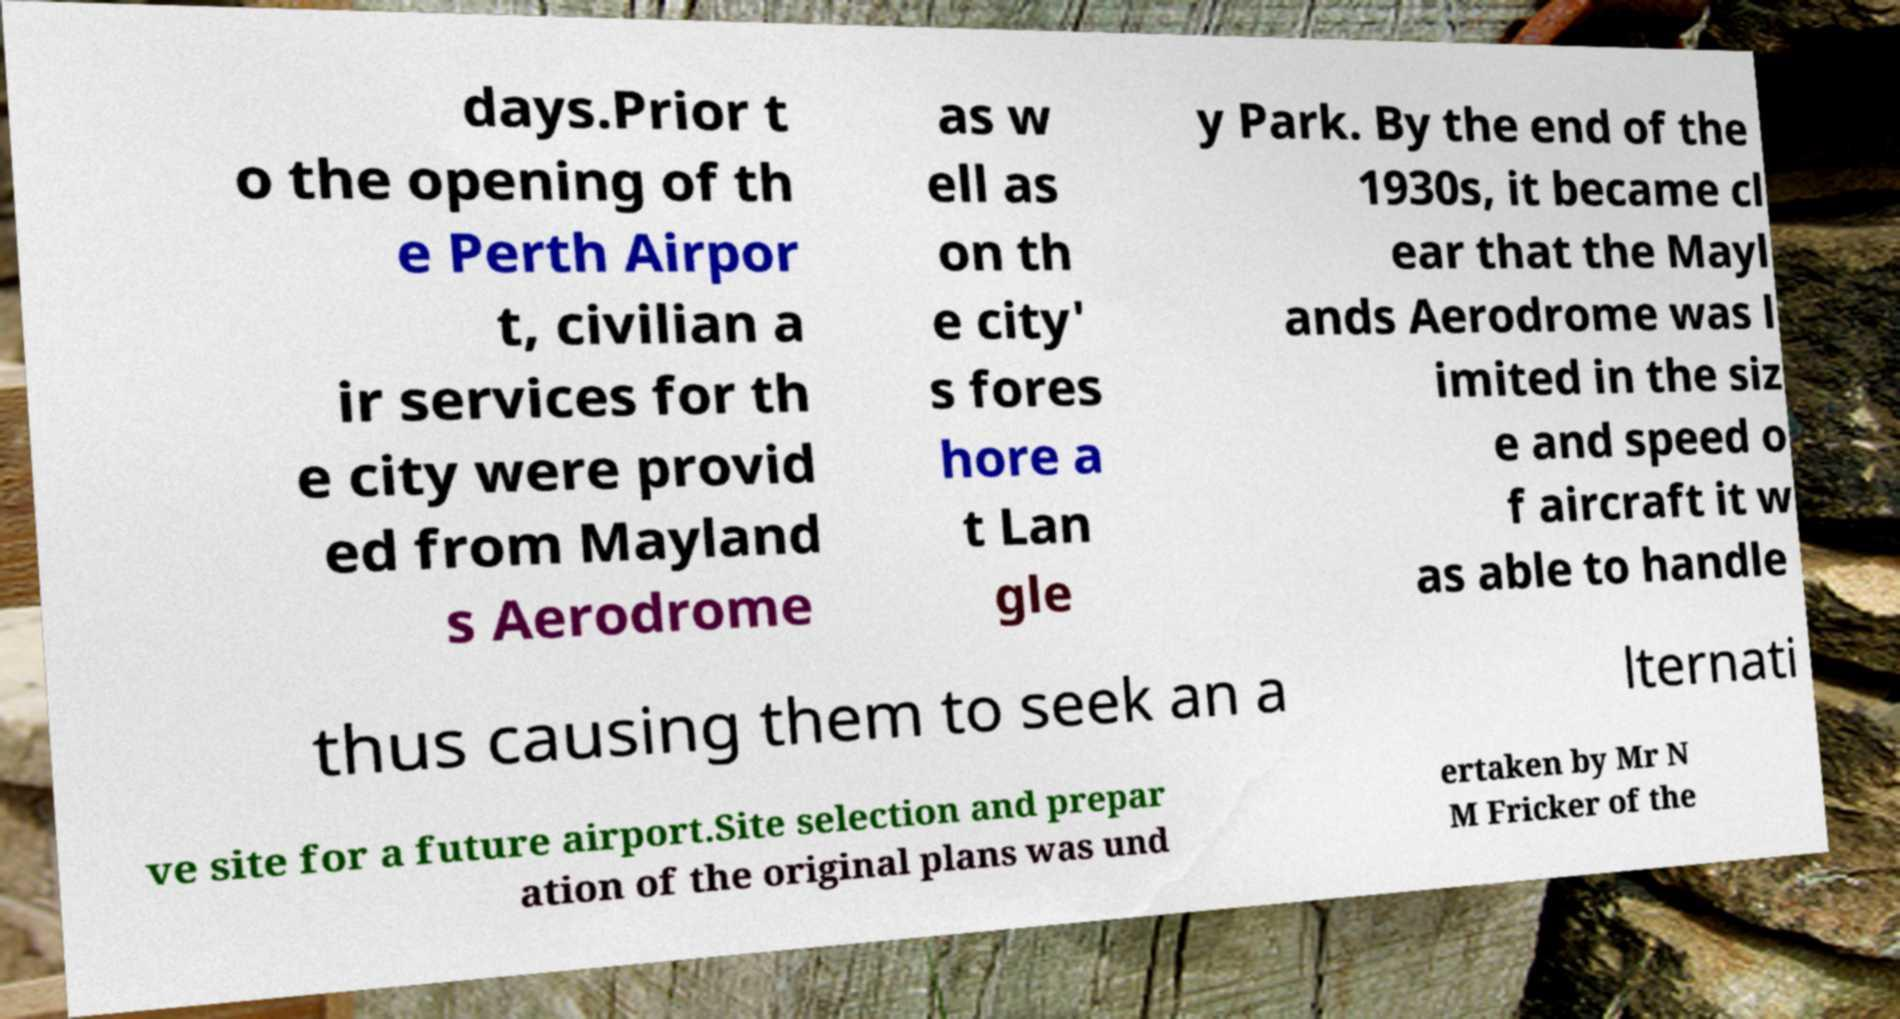I need the written content from this picture converted into text. Can you do that? days.Prior t o the opening of th e Perth Airpor t, civilian a ir services for th e city were provid ed from Mayland s Aerodrome as w ell as on th e city' s fores hore a t Lan gle y Park. By the end of the 1930s, it became cl ear that the Mayl ands Aerodrome was l imited in the siz e and speed o f aircraft it w as able to handle thus causing them to seek an a lternati ve site for a future airport.Site selection and prepar ation of the original plans was und ertaken by Mr N M Fricker of the 